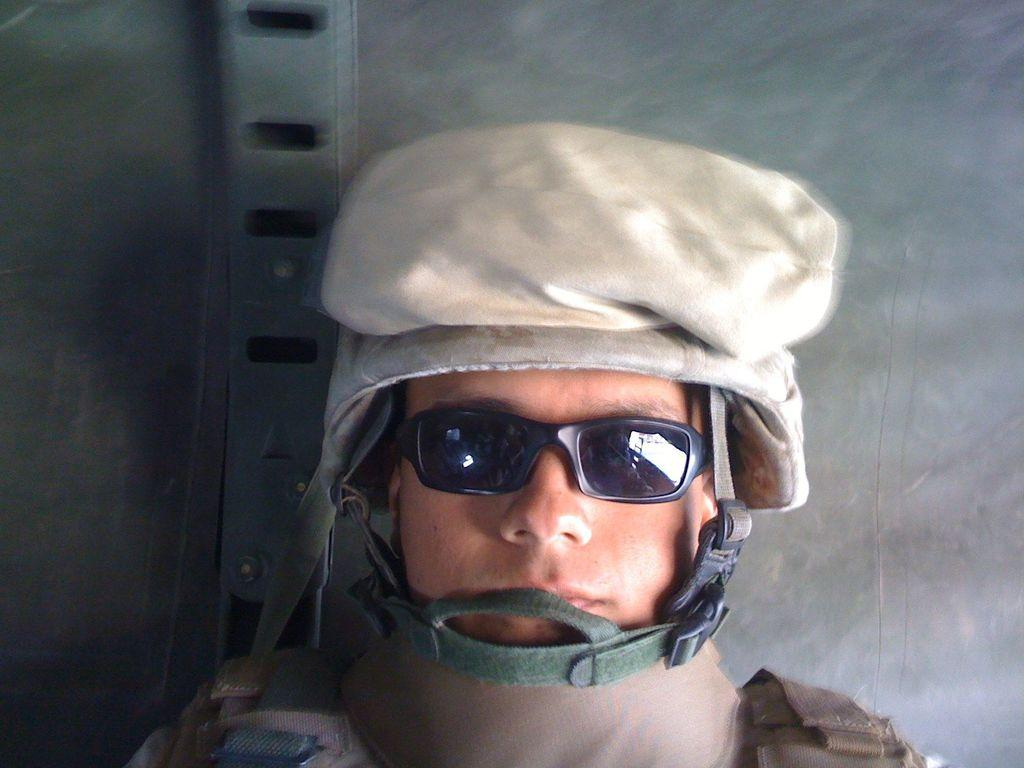Who is present in the image? There is a person in the image. What is the person wearing on their head? The person is wearing a cap. What type of eyewear is the person wearing? The person is wearing glasses. What is the color of the background in the image? The background of the image is in grey color. What type of war is depicted in the image? There is no depiction of war in the image; it features a person wearing a cap, glasses, and a dress against a grey background. How does the person use the comb in the image? There is no comb present in the image. 